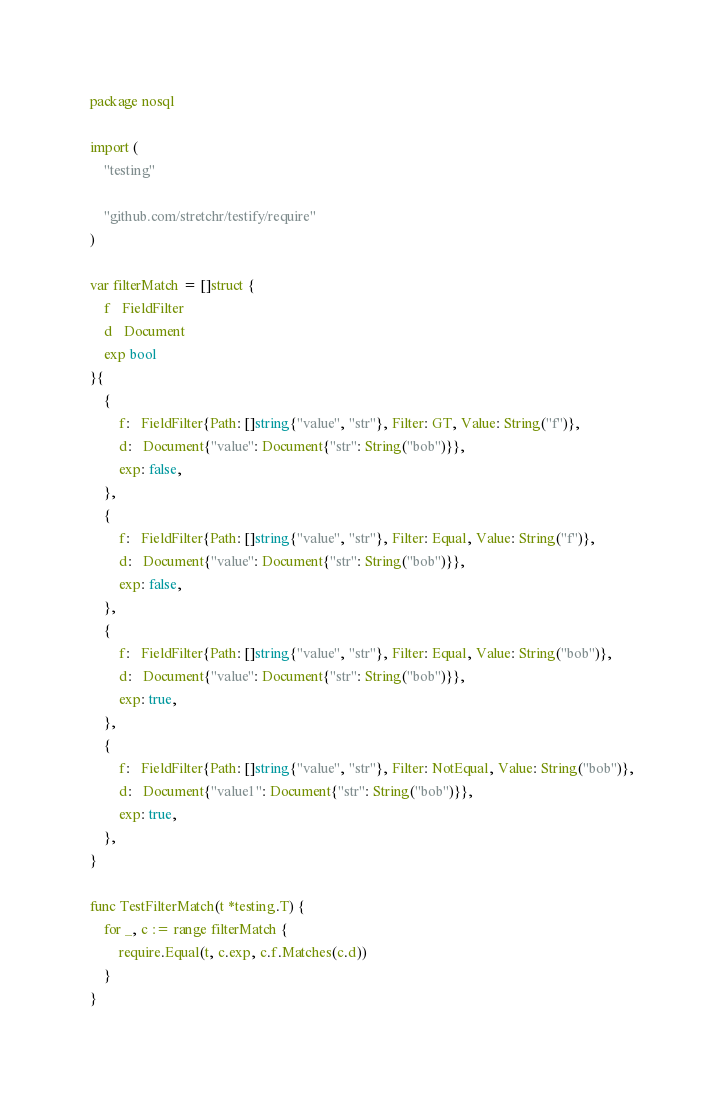Convert code to text. <code><loc_0><loc_0><loc_500><loc_500><_Go_>package nosql

import (
	"testing"

	"github.com/stretchr/testify/require"
)

var filterMatch = []struct {
	f   FieldFilter
	d   Document
	exp bool
}{
	{
		f:   FieldFilter{Path: []string{"value", "str"}, Filter: GT, Value: String("f")},
		d:   Document{"value": Document{"str": String("bob")}},
		exp: false,
	},
	{
		f:   FieldFilter{Path: []string{"value", "str"}, Filter: Equal, Value: String("f")},
		d:   Document{"value": Document{"str": String("bob")}},
		exp: false,
	},
	{
		f:   FieldFilter{Path: []string{"value", "str"}, Filter: Equal, Value: String("bob")},
		d:   Document{"value": Document{"str": String("bob")}},
		exp: true,
	},
	{
		f:   FieldFilter{Path: []string{"value", "str"}, Filter: NotEqual, Value: String("bob")},
		d:   Document{"value1": Document{"str": String("bob")}},
		exp: true,
	},
}

func TestFilterMatch(t *testing.T) {
	for _, c := range filterMatch {
		require.Equal(t, c.exp, c.f.Matches(c.d))
	}
}
</code> 